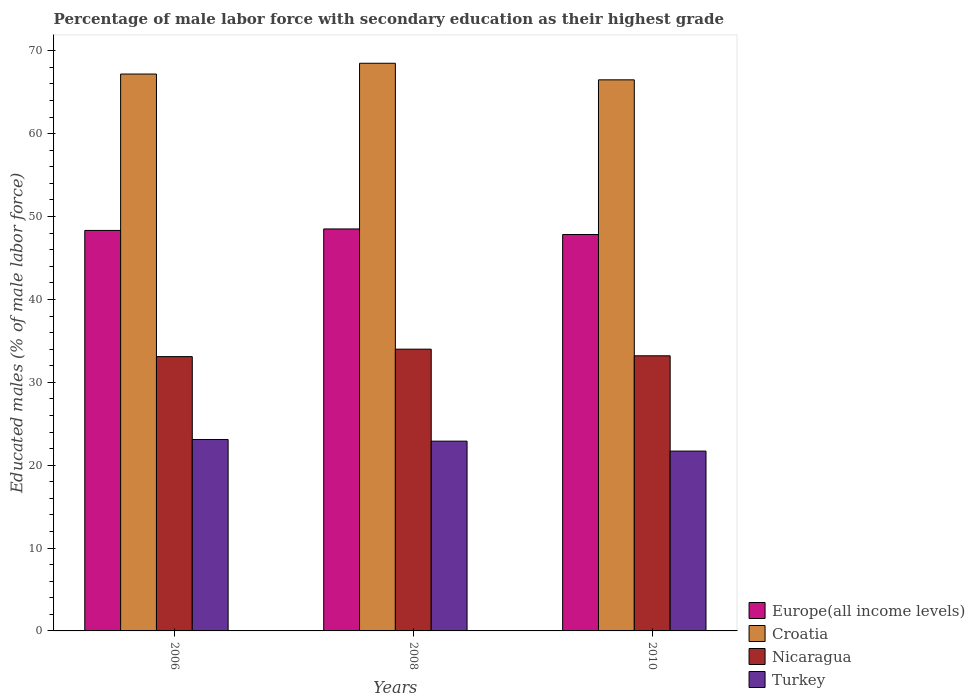How many different coloured bars are there?
Your answer should be very brief. 4. Are the number of bars on each tick of the X-axis equal?
Offer a very short reply. Yes. How many bars are there on the 1st tick from the left?
Offer a terse response. 4. How many bars are there on the 3rd tick from the right?
Offer a very short reply. 4. What is the percentage of male labor force with secondary education in Turkey in 2008?
Your answer should be very brief. 22.9. Across all years, what is the maximum percentage of male labor force with secondary education in Turkey?
Your answer should be compact. 23.1. Across all years, what is the minimum percentage of male labor force with secondary education in Europe(all income levels)?
Your answer should be compact. 47.83. What is the total percentage of male labor force with secondary education in Europe(all income levels) in the graph?
Make the answer very short. 144.67. What is the difference between the percentage of male labor force with secondary education in Turkey in 2006 and that in 2010?
Make the answer very short. 1.4. What is the difference between the percentage of male labor force with secondary education in Turkey in 2008 and the percentage of male labor force with secondary education in Croatia in 2006?
Keep it short and to the point. -44.3. What is the average percentage of male labor force with secondary education in Croatia per year?
Your answer should be very brief. 67.4. In the year 2006, what is the difference between the percentage of male labor force with secondary education in Nicaragua and percentage of male labor force with secondary education in Turkey?
Ensure brevity in your answer.  10. What is the ratio of the percentage of male labor force with secondary education in Nicaragua in 2008 to that in 2010?
Keep it short and to the point. 1.02. Is the percentage of male labor force with secondary education in Europe(all income levels) in 2008 less than that in 2010?
Keep it short and to the point. No. Is the difference between the percentage of male labor force with secondary education in Nicaragua in 2008 and 2010 greater than the difference between the percentage of male labor force with secondary education in Turkey in 2008 and 2010?
Make the answer very short. No. What is the difference between the highest and the second highest percentage of male labor force with secondary education in Croatia?
Give a very brief answer. 1.3. What is the difference between the highest and the lowest percentage of male labor force with secondary education in Nicaragua?
Ensure brevity in your answer.  0.9. Is the sum of the percentage of male labor force with secondary education in Turkey in 2008 and 2010 greater than the maximum percentage of male labor force with secondary education in Europe(all income levels) across all years?
Keep it short and to the point. No. What does the 4th bar from the left in 2010 represents?
Your answer should be compact. Turkey. What does the 4th bar from the right in 2006 represents?
Give a very brief answer. Europe(all income levels). Is it the case that in every year, the sum of the percentage of male labor force with secondary education in Turkey and percentage of male labor force with secondary education in Nicaragua is greater than the percentage of male labor force with secondary education in Europe(all income levels)?
Make the answer very short. Yes. Are all the bars in the graph horizontal?
Give a very brief answer. No. How many years are there in the graph?
Offer a very short reply. 3. Are the values on the major ticks of Y-axis written in scientific E-notation?
Ensure brevity in your answer.  No. Does the graph contain grids?
Provide a succinct answer. No. Where does the legend appear in the graph?
Provide a short and direct response. Bottom right. How are the legend labels stacked?
Keep it short and to the point. Vertical. What is the title of the graph?
Ensure brevity in your answer.  Percentage of male labor force with secondary education as their highest grade. What is the label or title of the X-axis?
Provide a succinct answer. Years. What is the label or title of the Y-axis?
Ensure brevity in your answer.  Educated males (% of male labor force). What is the Educated males (% of male labor force) of Europe(all income levels) in 2006?
Provide a succinct answer. 48.33. What is the Educated males (% of male labor force) of Croatia in 2006?
Give a very brief answer. 67.2. What is the Educated males (% of male labor force) in Nicaragua in 2006?
Give a very brief answer. 33.1. What is the Educated males (% of male labor force) in Turkey in 2006?
Offer a terse response. 23.1. What is the Educated males (% of male labor force) in Europe(all income levels) in 2008?
Ensure brevity in your answer.  48.51. What is the Educated males (% of male labor force) of Croatia in 2008?
Provide a short and direct response. 68.5. What is the Educated males (% of male labor force) of Turkey in 2008?
Your answer should be compact. 22.9. What is the Educated males (% of male labor force) in Europe(all income levels) in 2010?
Give a very brief answer. 47.83. What is the Educated males (% of male labor force) in Croatia in 2010?
Your response must be concise. 66.5. What is the Educated males (% of male labor force) of Nicaragua in 2010?
Your answer should be compact. 33.2. What is the Educated males (% of male labor force) of Turkey in 2010?
Make the answer very short. 21.7. Across all years, what is the maximum Educated males (% of male labor force) of Europe(all income levels)?
Give a very brief answer. 48.51. Across all years, what is the maximum Educated males (% of male labor force) of Croatia?
Offer a very short reply. 68.5. Across all years, what is the maximum Educated males (% of male labor force) in Turkey?
Provide a short and direct response. 23.1. Across all years, what is the minimum Educated males (% of male labor force) in Europe(all income levels)?
Keep it short and to the point. 47.83. Across all years, what is the minimum Educated males (% of male labor force) in Croatia?
Provide a short and direct response. 66.5. Across all years, what is the minimum Educated males (% of male labor force) of Nicaragua?
Give a very brief answer. 33.1. Across all years, what is the minimum Educated males (% of male labor force) of Turkey?
Keep it short and to the point. 21.7. What is the total Educated males (% of male labor force) in Europe(all income levels) in the graph?
Provide a short and direct response. 144.67. What is the total Educated males (% of male labor force) of Croatia in the graph?
Your response must be concise. 202.2. What is the total Educated males (% of male labor force) of Nicaragua in the graph?
Provide a short and direct response. 100.3. What is the total Educated males (% of male labor force) of Turkey in the graph?
Keep it short and to the point. 67.7. What is the difference between the Educated males (% of male labor force) of Europe(all income levels) in 2006 and that in 2008?
Ensure brevity in your answer.  -0.18. What is the difference between the Educated males (% of male labor force) of Croatia in 2006 and that in 2008?
Offer a terse response. -1.3. What is the difference between the Educated males (% of male labor force) of Europe(all income levels) in 2006 and that in 2010?
Make the answer very short. 0.49. What is the difference between the Educated males (% of male labor force) in Croatia in 2006 and that in 2010?
Give a very brief answer. 0.7. What is the difference between the Educated males (% of male labor force) in Europe(all income levels) in 2008 and that in 2010?
Offer a terse response. 0.67. What is the difference between the Educated males (% of male labor force) in Nicaragua in 2008 and that in 2010?
Provide a succinct answer. 0.8. What is the difference between the Educated males (% of male labor force) of Europe(all income levels) in 2006 and the Educated males (% of male labor force) of Croatia in 2008?
Your answer should be compact. -20.17. What is the difference between the Educated males (% of male labor force) in Europe(all income levels) in 2006 and the Educated males (% of male labor force) in Nicaragua in 2008?
Ensure brevity in your answer.  14.33. What is the difference between the Educated males (% of male labor force) of Europe(all income levels) in 2006 and the Educated males (% of male labor force) of Turkey in 2008?
Your answer should be very brief. 25.43. What is the difference between the Educated males (% of male labor force) of Croatia in 2006 and the Educated males (% of male labor force) of Nicaragua in 2008?
Keep it short and to the point. 33.2. What is the difference between the Educated males (% of male labor force) of Croatia in 2006 and the Educated males (% of male labor force) of Turkey in 2008?
Offer a terse response. 44.3. What is the difference between the Educated males (% of male labor force) of Europe(all income levels) in 2006 and the Educated males (% of male labor force) of Croatia in 2010?
Provide a short and direct response. -18.17. What is the difference between the Educated males (% of male labor force) of Europe(all income levels) in 2006 and the Educated males (% of male labor force) of Nicaragua in 2010?
Ensure brevity in your answer.  15.13. What is the difference between the Educated males (% of male labor force) of Europe(all income levels) in 2006 and the Educated males (% of male labor force) of Turkey in 2010?
Your response must be concise. 26.63. What is the difference between the Educated males (% of male labor force) of Croatia in 2006 and the Educated males (% of male labor force) of Turkey in 2010?
Ensure brevity in your answer.  45.5. What is the difference between the Educated males (% of male labor force) in Nicaragua in 2006 and the Educated males (% of male labor force) in Turkey in 2010?
Your answer should be very brief. 11.4. What is the difference between the Educated males (% of male labor force) of Europe(all income levels) in 2008 and the Educated males (% of male labor force) of Croatia in 2010?
Your response must be concise. -17.99. What is the difference between the Educated males (% of male labor force) in Europe(all income levels) in 2008 and the Educated males (% of male labor force) in Nicaragua in 2010?
Provide a short and direct response. 15.31. What is the difference between the Educated males (% of male labor force) in Europe(all income levels) in 2008 and the Educated males (% of male labor force) in Turkey in 2010?
Offer a terse response. 26.81. What is the difference between the Educated males (% of male labor force) of Croatia in 2008 and the Educated males (% of male labor force) of Nicaragua in 2010?
Offer a very short reply. 35.3. What is the difference between the Educated males (% of male labor force) in Croatia in 2008 and the Educated males (% of male labor force) in Turkey in 2010?
Give a very brief answer. 46.8. What is the difference between the Educated males (% of male labor force) of Nicaragua in 2008 and the Educated males (% of male labor force) of Turkey in 2010?
Make the answer very short. 12.3. What is the average Educated males (% of male labor force) in Europe(all income levels) per year?
Give a very brief answer. 48.22. What is the average Educated males (% of male labor force) in Croatia per year?
Provide a short and direct response. 67.4. What is the average Educated males (% of male labor force) in Nicaragua per year?
Your answer should be compact. 33.43. What is the average Educated males (% of male labor force) in Turkey per year?
Give a very brief answer. 22.57. In the year 2006, what is the difference between the Educated males (% of male labor force) in Europe(all income levels) and Educated males (% of male labor force) in Croatia?
Your answer should be compact. -18.87. In the year 2006, what is the difference between the Educated males (% of male labor force) of Europe(all income levels) and Educated males (% of male labor force) of Nicaragua?
Provide a short and direct response. 15.23. In the year 2006, what is the difference between the Educated males (% of male labor force) of Europe(all income levels) and Educated males (% of male labor force) of Turkey?
Make the answer very short. 25.23. In the year 2006, what is the difference between the Educated males (% of male labor force) in Croatia and Educated males (% of male labor force) in Nicaragua?
Keep it short and to the point. 34.1. In the year 2006, what is the difference between the Educated males (% of male labor force) in Croatia and Educated males (% of male labor force) in Turkey?
Provide a succinct answer. 44.1. In the year 2006, what is the difference between the Educated males (% of male labor force) in Nicaragua and Educated males (% of male labor force) in Turkey?
Make the answer very short. 10. In the year 2008, what is the difference between the Educated males (% of male labor force) of Europe(all income levels) and Educated males (% of male labor force) of Croatia?
Your answer should be very brief. -19.99. In the year 2008, what is the difference between the Educated males (% of male labor force) of Europe(all income levels) and Educated males (% of male labor force) of Nicaragua?
Your answer should be very brief. 14.51. In the year 2008, what is the difference between the Educated males (% of male labor force) in Europe(all income levels) and Educated males (% of male labor force) in Turkey?
Ensure brevity in your answer.  25.61. In the year 2008, what is the difference between the Educated males (% of male labor force) of Croatia and Educated males (% of male labor force) of Nicaragua?
Give a very brief answer. 34.5. In the year 2008, what is the difference between the Educated males (% of male labor force) of Croatia and Educated males (% of male labor force) of Turkey?
Provide a short and direct response. 45.6. In the year 2008, what is the difference between the Educated males (% of male labor force) of Nicaragua and Educated males (% of male labor force) of Turkey?
Ensure brevity in your answer.  11.1. In the year 2010, what is the difference between the Educated males (% of male labor force) of Europe(all income levels) and Educated males (% of male labor force) of Croatia?
Your response must be concise. -18.67. In the year 2010, what is the difference between the Educated males (% of male labor force) of Europe(all income levels) and Educated males (% of male labor force) of Nicaragua?
Your answer should be very brief. 14.63. In the year 2010, what is the difference between the Educated males (% of male labor force) in Europe(all income levels) and Educated males (% of male labor force) in Turkey?
Your response must be concise. 26.13. In the year 2010, what is the difference between the Educated males (% of male labor force) in Croatia and Educated males (% of male labor force) in Nicaragua?
Your response must be concise. 33.3. In the year 2010, what is the difference between the Educated males (% of male labor force) in Croatia and Educated males (% of male labor force) in Turkey?
Keep it short and to the point. 44.8. In the year 2010, what is the difference between the Educated males (% of male labor force) in Nicaragua and Educated males (% of male labor force) in Turkey?
Your answer should be very brief. 11.5. What is the ratio of the Educated males (% of male labor force) of Europe(all income levels) in 2006 to that in 2008?
Make the answer very short. 1. What is the ratio of the Educated males (% of male labor force) in Nicaragua in 2006 to that in 2008?
Keep it short and to the point. 0.97. What is the ratio of the Educated males (% of male labor force) in Turkey in 2006 to that in 2008?
Offer a terse response. 1.01. What is the ratio of the Educated males (% of male labor force) of Europe(all income levels) in 2006 to that in 2010?
Your answer should be very brief. 1.01. What is the ratio of the Educated males (% of male labor force) in Croatia in 2006 to that in 2010?
Give a very brief answer. 1.01. What is the ratio of the Educated males (% of male labor force) of Nicaragua in 2006 to that in 2010?
Provide a succinct answer. 1. What is the ratio of the Educated males (% of male labor force) in Turkey in 2006 to that in 2010?
Offer a terse response. 1.06. What is the ratio of the Educated males (% of male labor force) in Europe(all income levels) in 2008 to that in 2010?
Your answer should be very brief. 1.01. What is the ratio of the Educated males (% of male labor force) in Croatia in 2008 to that in 2010?
Offer a terse response. 1.03. What is the ratio of the Educated males (% of male labor force) of Nicaragua in 2008 to that in 2010?
Your answer should be very brief. 1.02. What is the ratio of the Educated males (% of male labor force) in Turkey in 2008 to that in 2010?
Keep it short and to the point. 1.06. What is the difference between the highest and the second highest Educated males (% of male labor force) in Europe(all income levels)?
Your answer should be very brief. 0.18. What is the difference between the highest and the second highest Educated males (% of male labor force) of Croatia?
Ensure brevity in your answer.  1.3. What is the difference between the highest and the second highest Educated males (% of male labor force) in Nicaragua?
Make the answer very short. 0.8. What is the difference between the highest and the lowest Educated males (% of male labor force) of Europe(all income levels)?
Provide a short and direct response. 0.67. What is the difference between the highest and the lowest Educated males (% of male labor force) in Croatia?
Offer a terse response. 2. What is the difference between the highest and the lowest Educated males (% of male labor force) of Nicaragua?
Your answer should be compact. 0.9. What is the difference between the highest and the lowest Educated males (% of male labor force) in Turkey?
Offer a terse response. 1.4. 